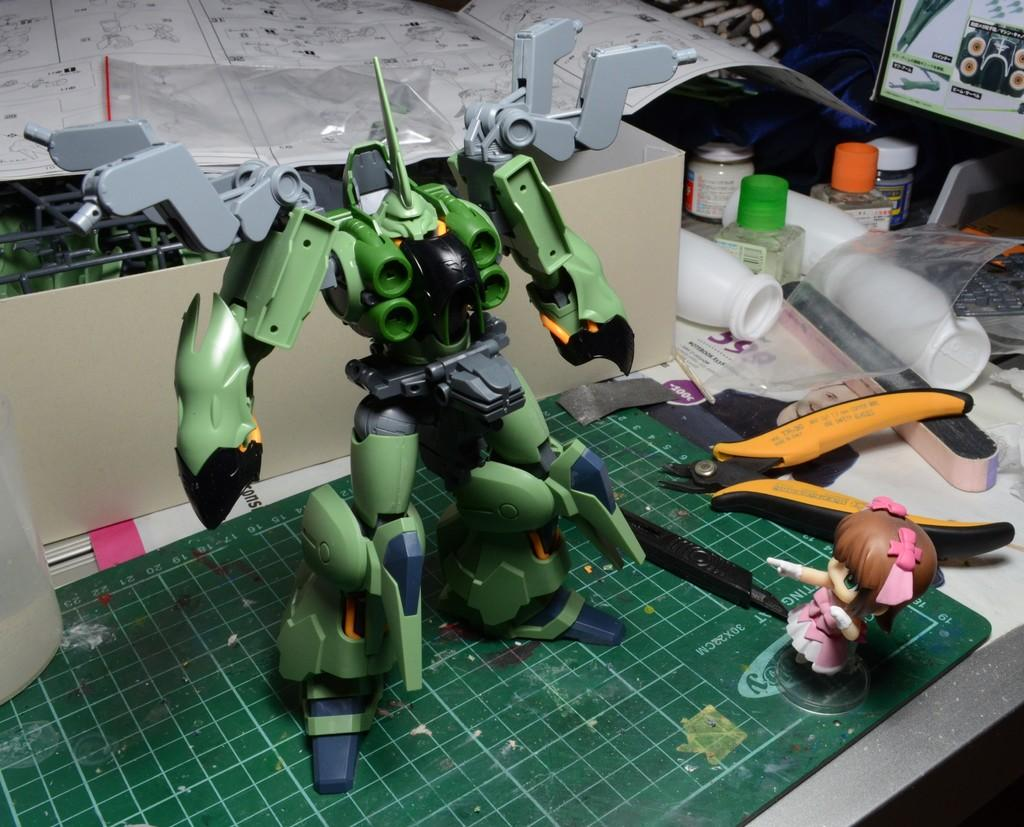What type of items can be seen on the table in the image? There are toys, a cutter, a box, bottles, a screen, papers, and other objects on the table. Can you describe the screen on the table? Unfortunately, the facts provided do not give any details about the screen, so we cannot describe it. What might be the purpose of the cutter on the table? The cutter on the table might be used for cutting or slicing various materials, but the specific purpose cannot be determined from the facts provided. How many objects are visible on the table in the image? There are at least eight objects visible on the table: toys, a cutter, a box, bottles, a screen, papers, and other objects. How steep is the slope on the table in the image? There is no slope present on the table in the image. 